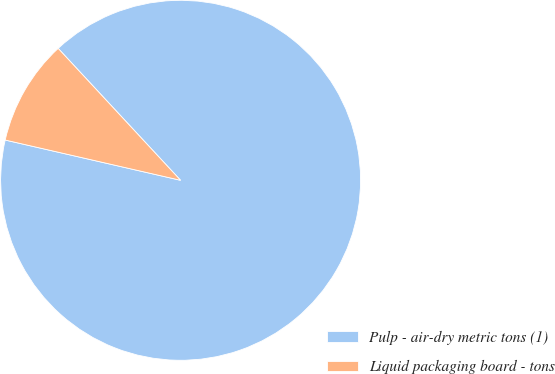Convert chart to OTSL. <chart><loc_0><loc_0><loc_500><loc_500><pie_chart><fcel>Pulp - air-dry metric tons (1)<fcel>Liquid packaging board - tons<nl><fcel>90.5%<fcel>9.5%<nl></chart> 